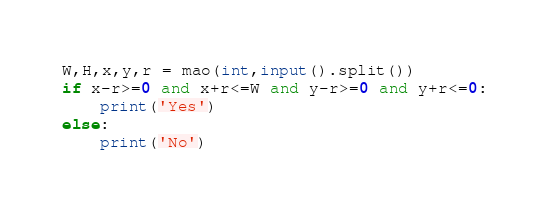Convert code to text. <code><loc_0><loc_0><loc_500><loc_500><_Python_>W,H,x,y,r = mao(int,input().split())
if x-r>=0 and x+r<=W and y-r>=0 and y+r<=0:
    print('Yes')
else:
    print('No')
</code> 